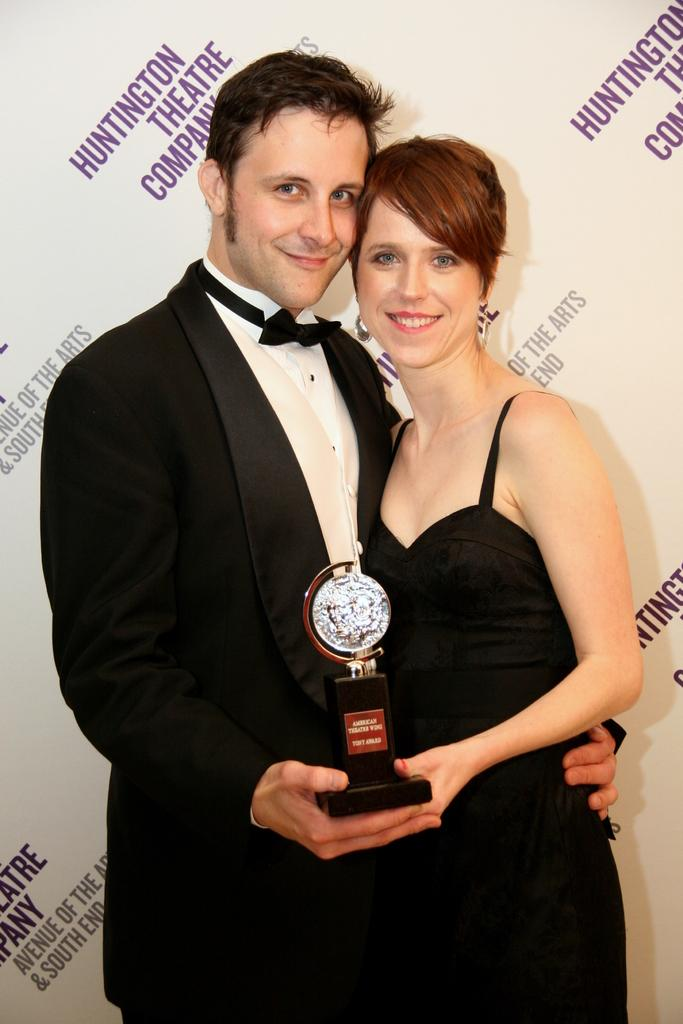<image>
Render a clear and concise summary of the photo. A man and woman hold an award at a Huntington Theatre Company. 